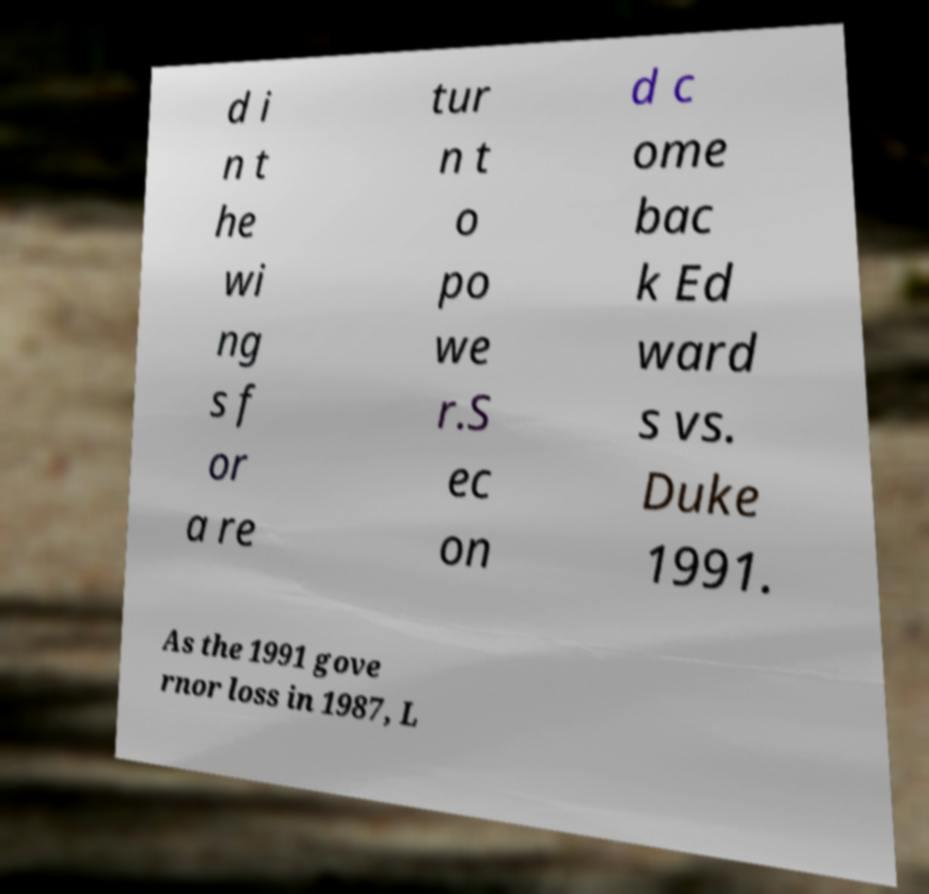For documentation purposes, I need the text within this image transcribed. Could you provide that? d i n t he wi ng s f or a re tur n t o po we r.S ec on d c ome bac k Ed ward s vs. Duke 1991. As the 1991 gove rnor loss in 1987, L 